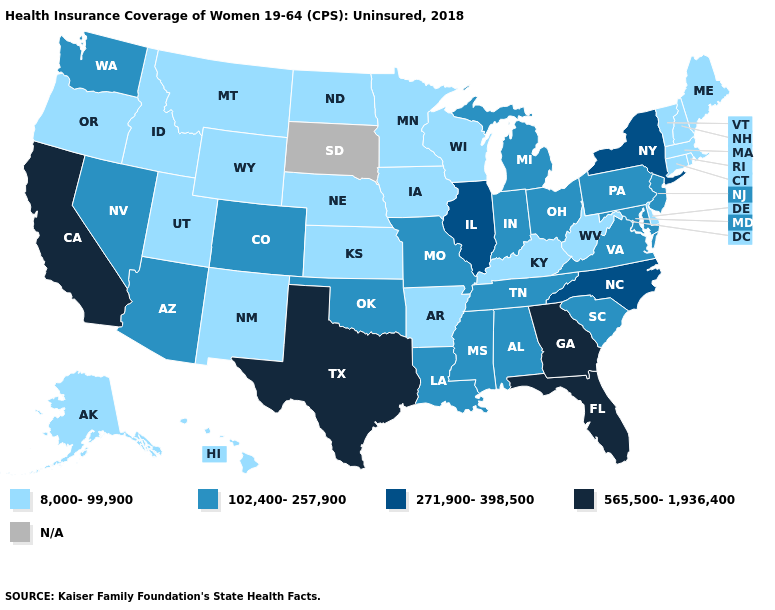Does Wisconsin have the lowest value in the MidWest?
Short answer required. Yes. Among the states that border Maryland , which have the highest value?
Write a very short answer. Pennsylvania, Virginia. What is the value of Oklahoma?
Concise answer only. 102,400-257,900. What is the value of Nevada?
Answer briefly. 102,400-257,900. Is the legend a continuous bar?
Keep it brief. No. Which states have the highest value in the USA?
Write a very short answer. California, Florida, Georgia, Texas. What is the highest value in the West ?
Answer briefly. 565,500-1,936,400. What is the lowest value in the South?
Keep it brief. 8,000-99,900. What is the lowest value in the West?
Answer briefly. 8,000-99,900. Which states have the lowest value in the MidWest?
Short answer required. Iowa, Kansas, Minnesota, Nebraska, North Dakota, Wisconsin. Which states hav the highest value in the MidWest?
Answer briefly. Illinois. Name the states that have a value in the range 565,500-1,936,400?
Quick response, please. California, Florida, Georgia, Texas. Among the states that border Colorado , which have the lowest value?
Concise answer only. Kansas, Nebraska, New Mexico, Utah, Wyoming. Does New Jersey have the highest value in the USA?
Be succinct. No. What is the value of Vermont?
Quick response, please. 8,000-99,900. 